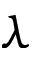<formula> <loc_0><loc_0><loc_500><loc_500>\lambda</formula> 